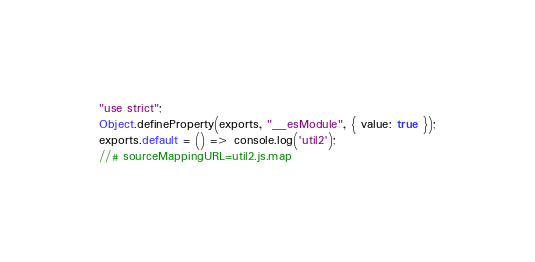<code> <loc_0><loc_0><loc_500><loc_500><_JavaScript_>"use strict";
Object.defineProperty(exports, "__esModule", { value: true });
exports.default = () => console.log('util2');
//# sourceMappingURL=util2.js.map</code> 